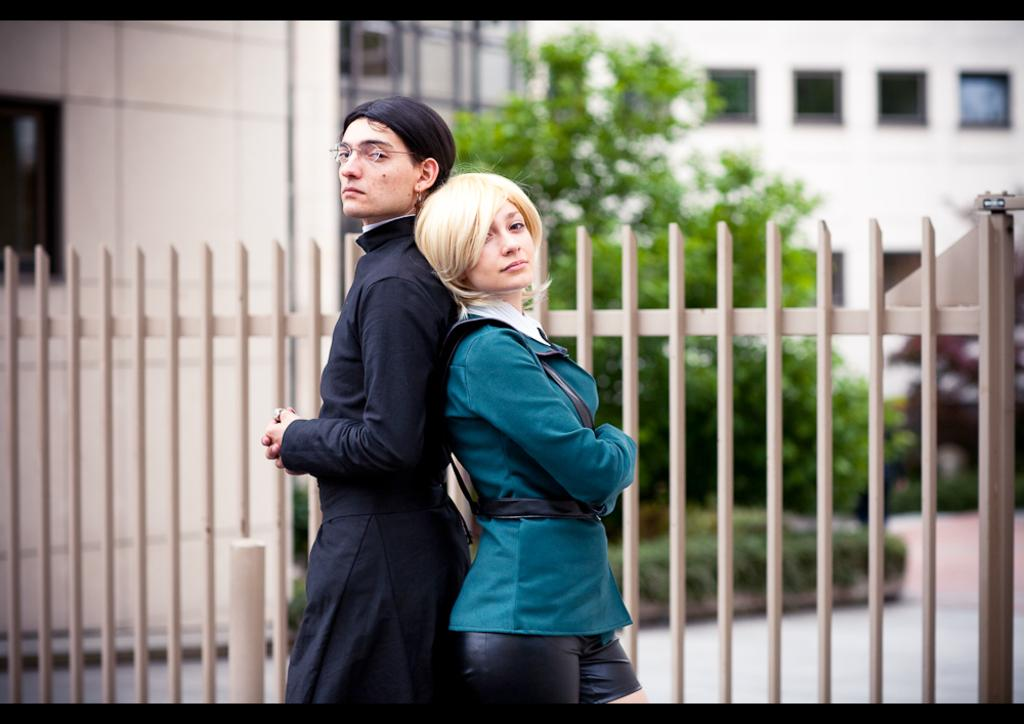How many people are in the image? There are two persons in the image. What are the two persons doing? The two persons are posing for a photo. What can be seen behind the persons? There are trees, garden plants, buildings, and a fence visible in the background. What type of apparel is on the list that the persons are holding in the image? There is no list or apparel present in the image; the two persons are posing for a photo. 